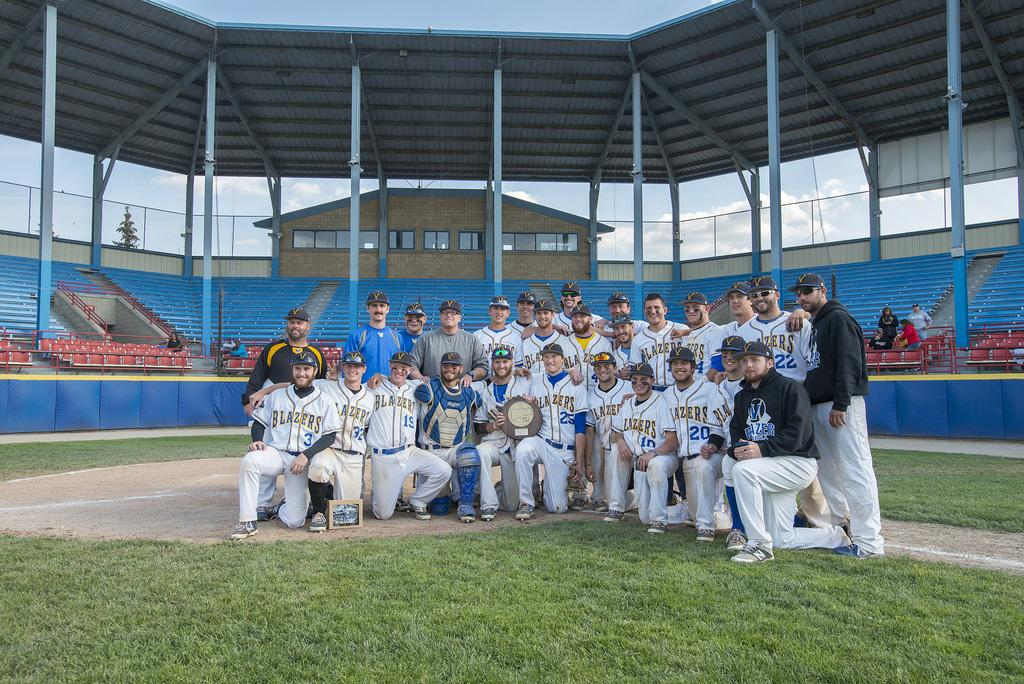<image>
Present a compact description of the photo's key features. Group photo for the baseball team named Blazers. 